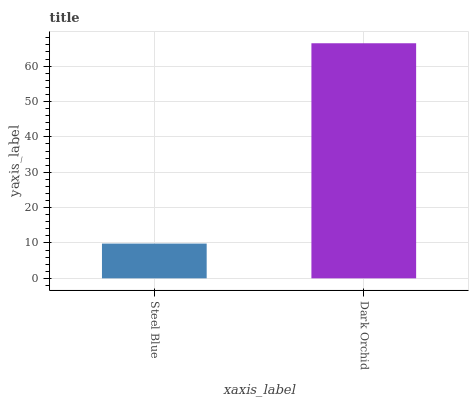Is Dark Orchid the minimum?
Answer yes or no. No. Is Dark Orchid greater than Steel Blue?
Answer yes or no. Yes. Is Steel Blue less than Dark Orchid?
Answer yes or no. Yes. Is Steel Blue greater than Dark Orchid?
Answer yes or no. No. Is Dark Orchid less than Steel Blue?
Answer yes or no. No. Is Dark Orchid the high median?
Answer yes or no. Yes. Is Steel Blue the low median?
Answer yes or no. Yes. Is Steel Blue the high median?
Answer yes or no. No. Is Dark Orchid the low median?
Answer yes or no. No. 